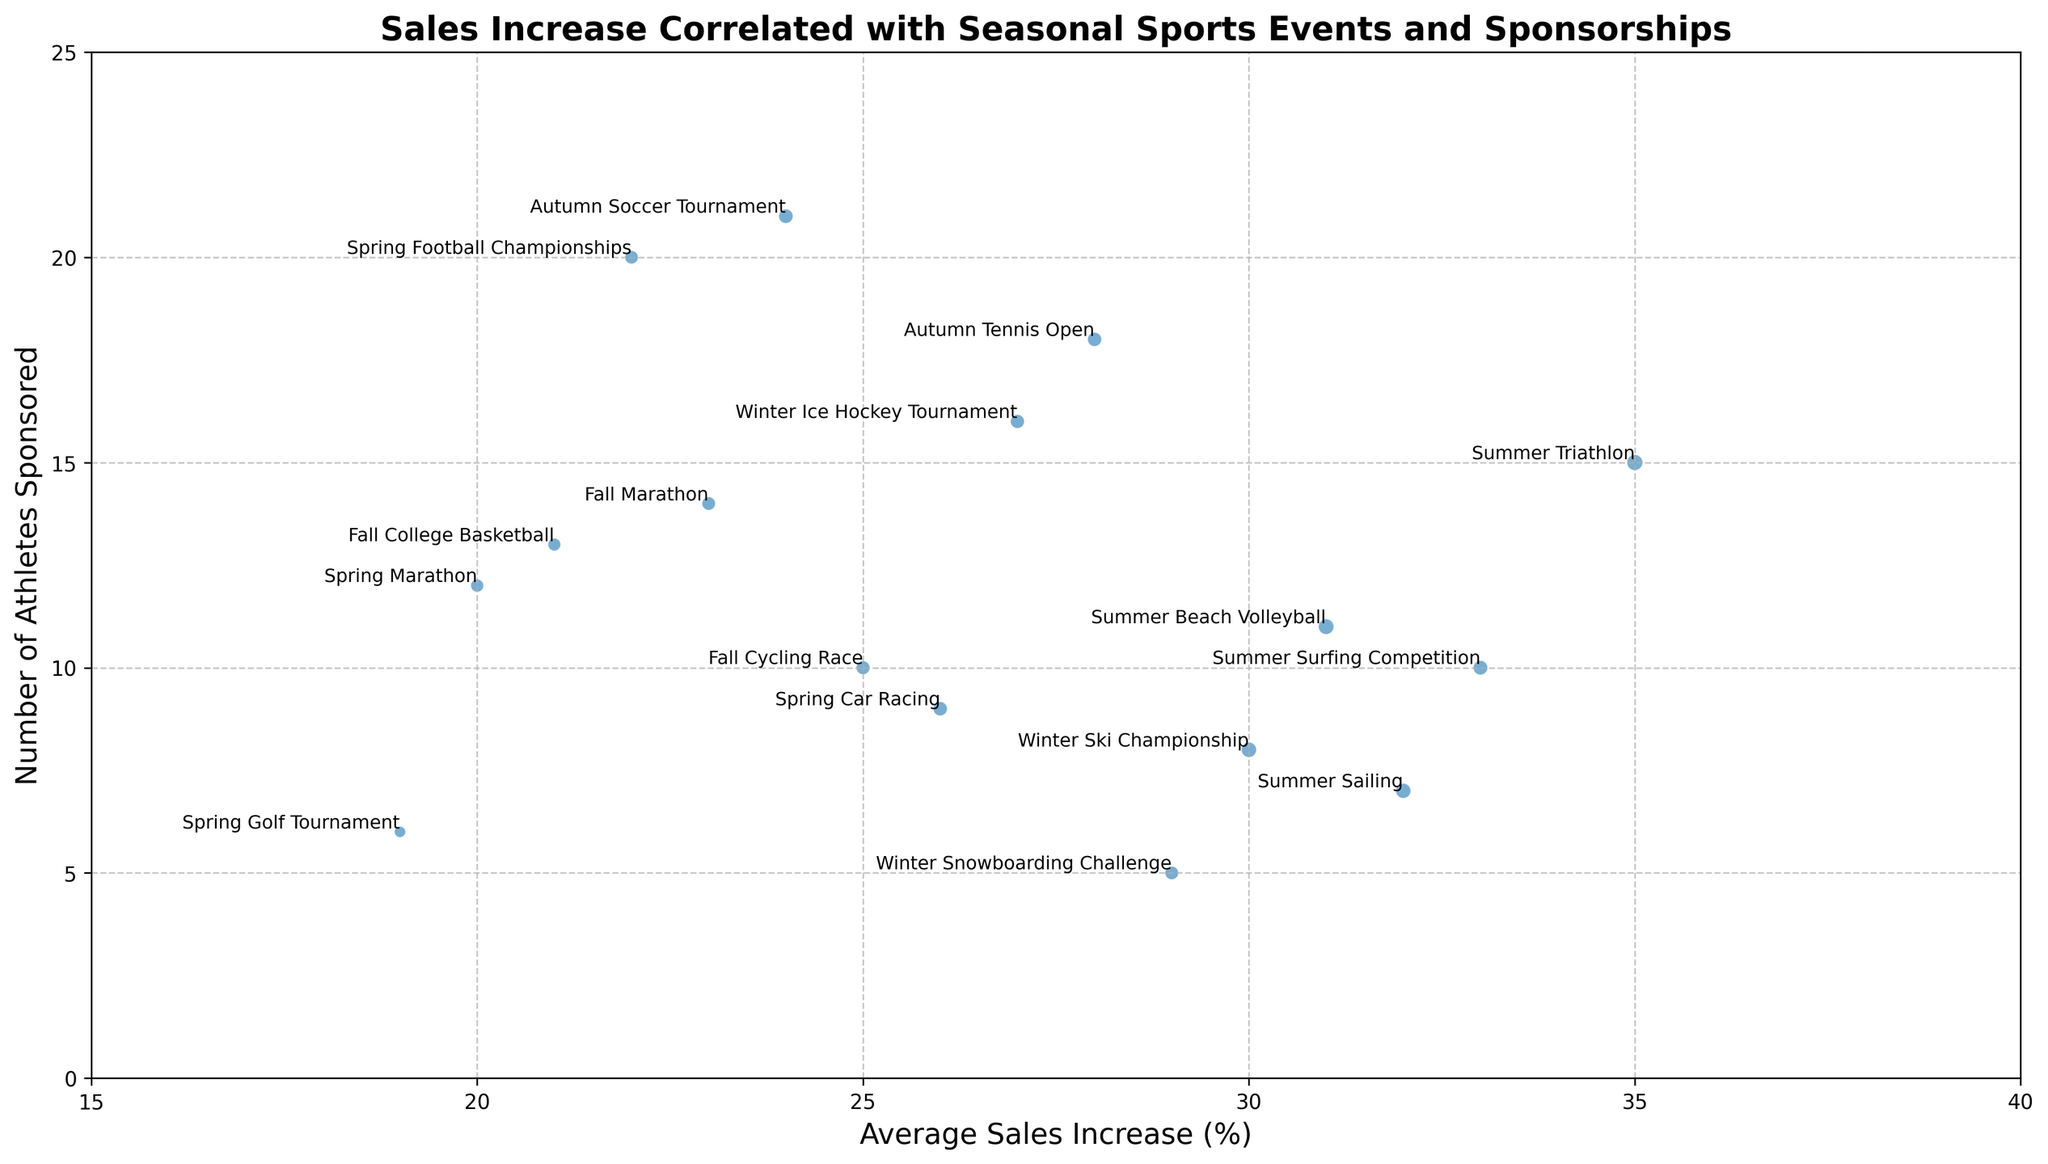What event has the highest average sales increase? The event with the highest average sales increase can be identified by looking at the x-axis values and finding the maximum. In this case, the Summer Triathlon has the highest value of 35%.
Answer: Summer Triathlon Which event has the highest number of athletes sponsored and what is its average sales increase? The event with the highest number of athletes sponsored can be identified by looking at the maximum y-axis value. The Autumn Soccer Tournament sponsors 21 athletes, and its average sales increase is 24%.
Answer: Autumn Soccer Tournament, 24% Compare the budget allocated for the Summer Triathlon and the Winter Ski Championship. Which one is higher and by how much? The Summer Triathlon has a budget of $120,000, and the Winter Ski Championship has $110,000. The difference is $120,000 - $110,000 = $10,000.
Answer: Summer Triathlon, $10,000 What's the total number of athletes sponsored in all Spring events? Summing the number of athletes sponsored in Spring events: Spring Marathon (12), Spring Football Championships (20), Spring Car Racing (9), and Spring Golf Tournament (6). Total is 12 + 20 + 9 + 6 = 47.
Answer: 47 What is the average budget allocated across all events? The total budget is the sum of all budget values, which is $80,000 + $120,000 + $90,000 + $110,000 + $95,000 + $85,000 + $100,000 + $87,000 + $93,000 + $96,000 + $115,000 + $78,000 + $60,000 + $108,000 + $87,000 + $98,000 = $1,422,000. There are 16 events, so the average budget is $1,422,000 / 16 = $88,875.
Answer: $88,875 How does the average sales increase of the Summer Surfing Competition compare to the Winter Snowboarding Challenge? The Summer Surfing Competition has an average sales increase of 33%, while the Winter Snowboarding Challenge has 29%. 33% is greater than 29%.
Answer: 33% > 29% Which event has an average sales increase closest to 25%? Looking at x-axis values, the Fall Cycling Race has an average sales increase of 25%, which is equal to 25%.
Answer: Fall Cycling Race What is the total sales increase for all events happening in the Winter season? Summing the average sales increase for Winter events: Winter Ski Championship (30%), Winter Ice Hockey Tournament (27%), Winter Snowboarding Challenge (29%). Total is 30% + 27% + 29% = 86%.
Answer: 86% Compare the impact of the Spring Marathon and the Fall Marathon in terms of sales increase and number of athletes sponsored. Which has a higher sales increase, and which sponsors more athletes? The Spring Marathon has a sales increase of 20% and sponsors 12 athletes, while the Fall Marathon has a sales increase of 23% and sponsors 14 athletes. Fall Marathon has a higher sales increase (23% vs. 20%) and sponsors more athletes (14 vs. 12).
Answer: Fall Marathon Which event represents the lowest budget and what is its average sales increase and number of athletes sponsored? The Spring Golf Tournament has the lowest budget of $60,000. Its average sales increase is 19%, and it sponsors 6 athletes.
Answer: Spring Golf Tournament, 19%, 6 athletes 